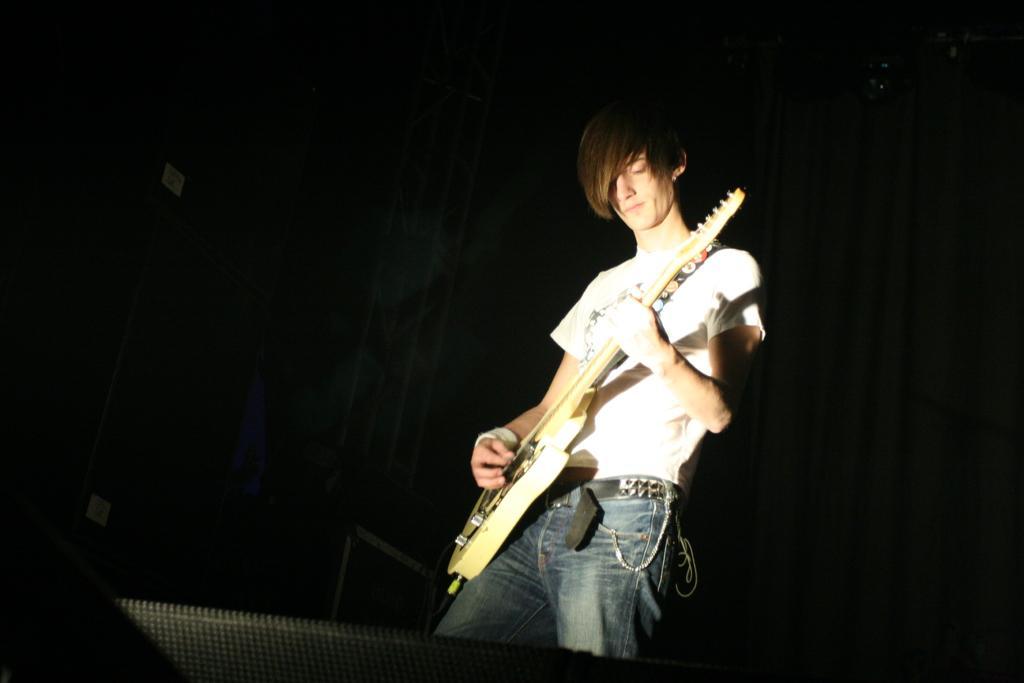Could you give a brief overview of what you see in this image? In this image, we can see a person playing a guitar. Background there is a dark view. Here we can see few rods. At the bottom, we can see the black color object. 